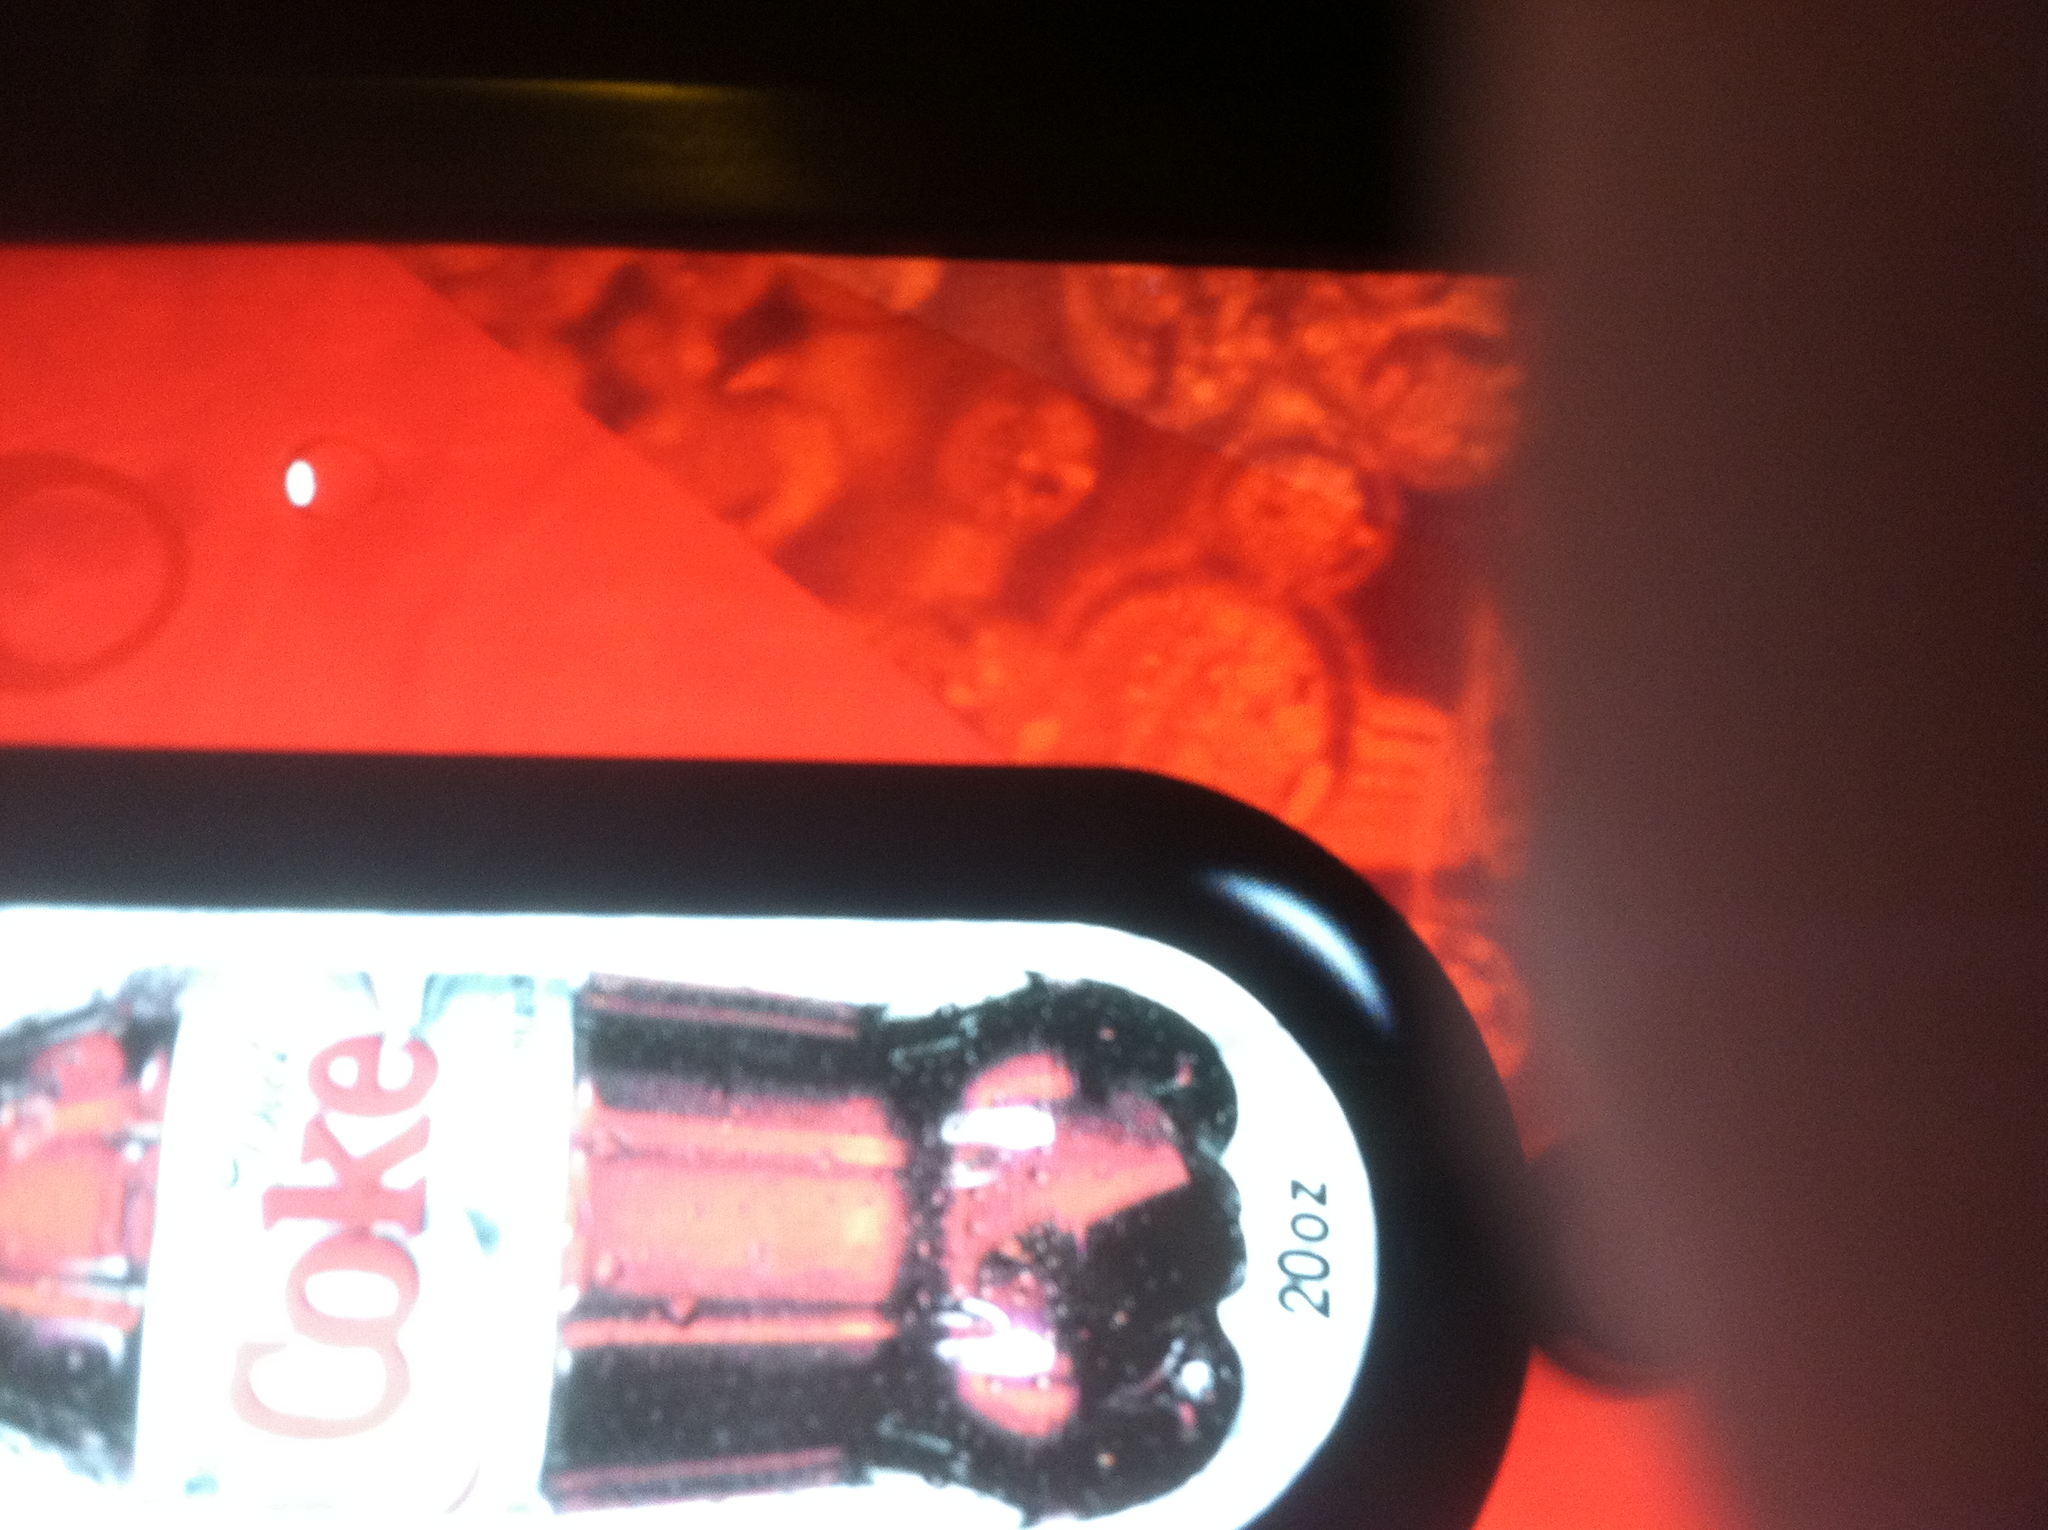What story do you think the designers of this product wanted to tell with this particular design? The designers likely wanted to communicate a story of modernity and energy with this Diet Coke product. The use of sleek silver paired with vibrant red highlights how the drink is both a fashionable and smart choice for today's consumer who is health-conscious but does not want to sacrifice taste or satisfaction. The condensation droplets on the bottle suggest it's refreshingly cool, making it the perfect beverage for quenching thirst and invigorating at any time. 